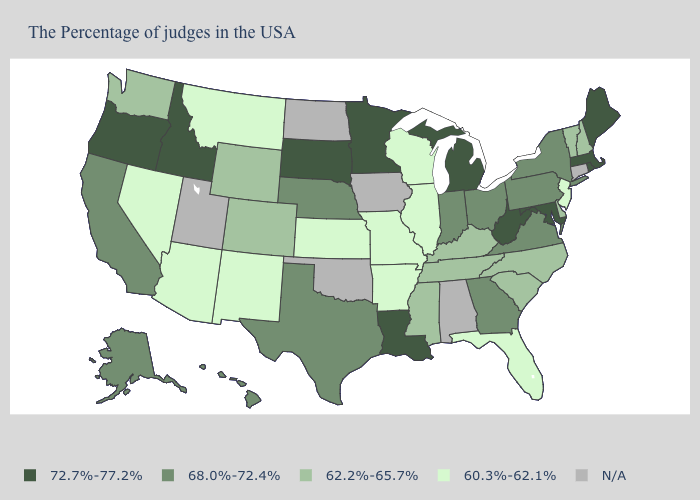Among the states that border Rhode Island , which have the lowest value?
Give a very brief answer. Massachusetts. Name the states that have a value in the range 68.0%-72.4%?
Concise answer only. New York, Pennsylvania, Virginia, Ohio, Georgia, Indiana, Nebraska, Texas, California, Alaska, Hawaii. Is the legend a continuous bar?
Write a very short answer. No. What is the value of Arizona?
Give a very brief answer. 60.3%-62.1%. Name the states that have a value in the range 62.2%-65.7%?
Short answer required. New Hampshire, Vermont, Delaware, North Carolina, South Carolina, Kentucky, Tennessee, Mississippi, Wyoming, Colorado, Washington. What is the lowest value in the USA?
Keep it brief. 60.3%-62.1%. What is the lowest value in the USA?
Give a very brief answer. 60.3%-62.1%. Name the states that have a value in the range 62.2%-65.7%?
Concise answer only. New Hampshire, Vermont, Delaware, North Carolina, South Carolina, Kentucky, Tennessee, Mississippi, Wyoming, Colorado, Washington. What is the value of Louisiana?
Concise answer only. 72.7%-77.2%. What is the highest value in states that border Louisiana?
Short answer required. 68.0%-72.4%. Among the states that border Colorado , does New Mexico have the highest value?
Be succinct. No. Name the states that have a value in the range 60.3%-62.1%?
Give a very brief answer. New Jersey, Florida, Wisconsin, Illinois, Missouri, Arkansas, Kansas, New Mexico, Montana, Arizona, Nevada. Name the states that have a value in the range 62.2%-65.7%?
Write a very short answer. New Hampshire, Vermont, Delaware, North Carolina, South Carolina, Kentucky, Tennessee, Mississippi, Wyoming, Colorado, Washington. Name the states that have a value in the range 72.7%-77.2%?
Concise answer only. Maine, Massachusetts, Rhode Island, Maryland, West Virginia, Michigan, Louisiana, Minnesota, South Dakota, Idaho, Oregon. Name the states that have a value in the range 60.3%-62.1%?
Give a very brief answer. New Jersey, Florida, Wisconsin, Illinois, Missouri, Arkansas, Kansas, New Mexico, Montana, Arizona, Nevada. 